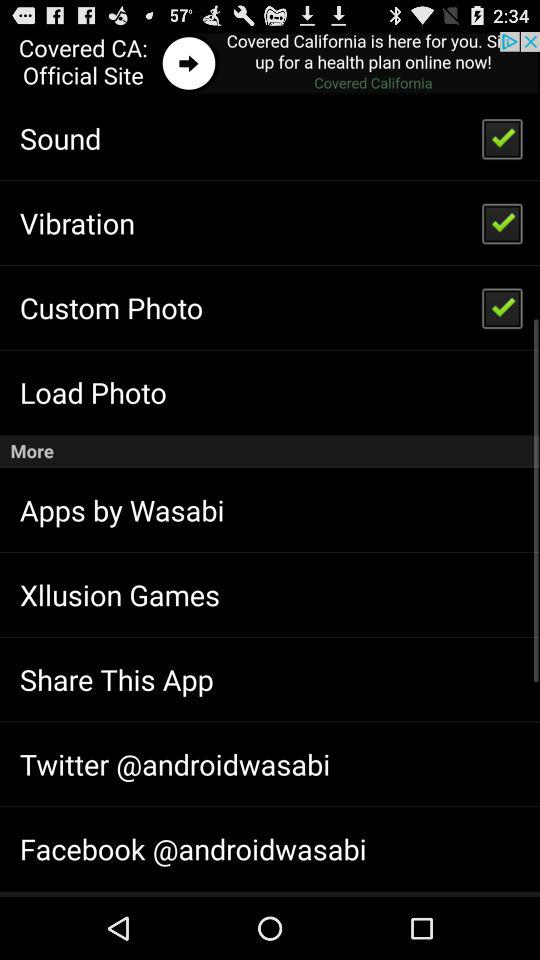What is the status of the "Custom Photo" setting? The status of the "Custom Photo" setting is "on". 